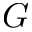Convert formula to latex. <formula><loc_0><loc_0><loc_500><loc_500>G</formula> 